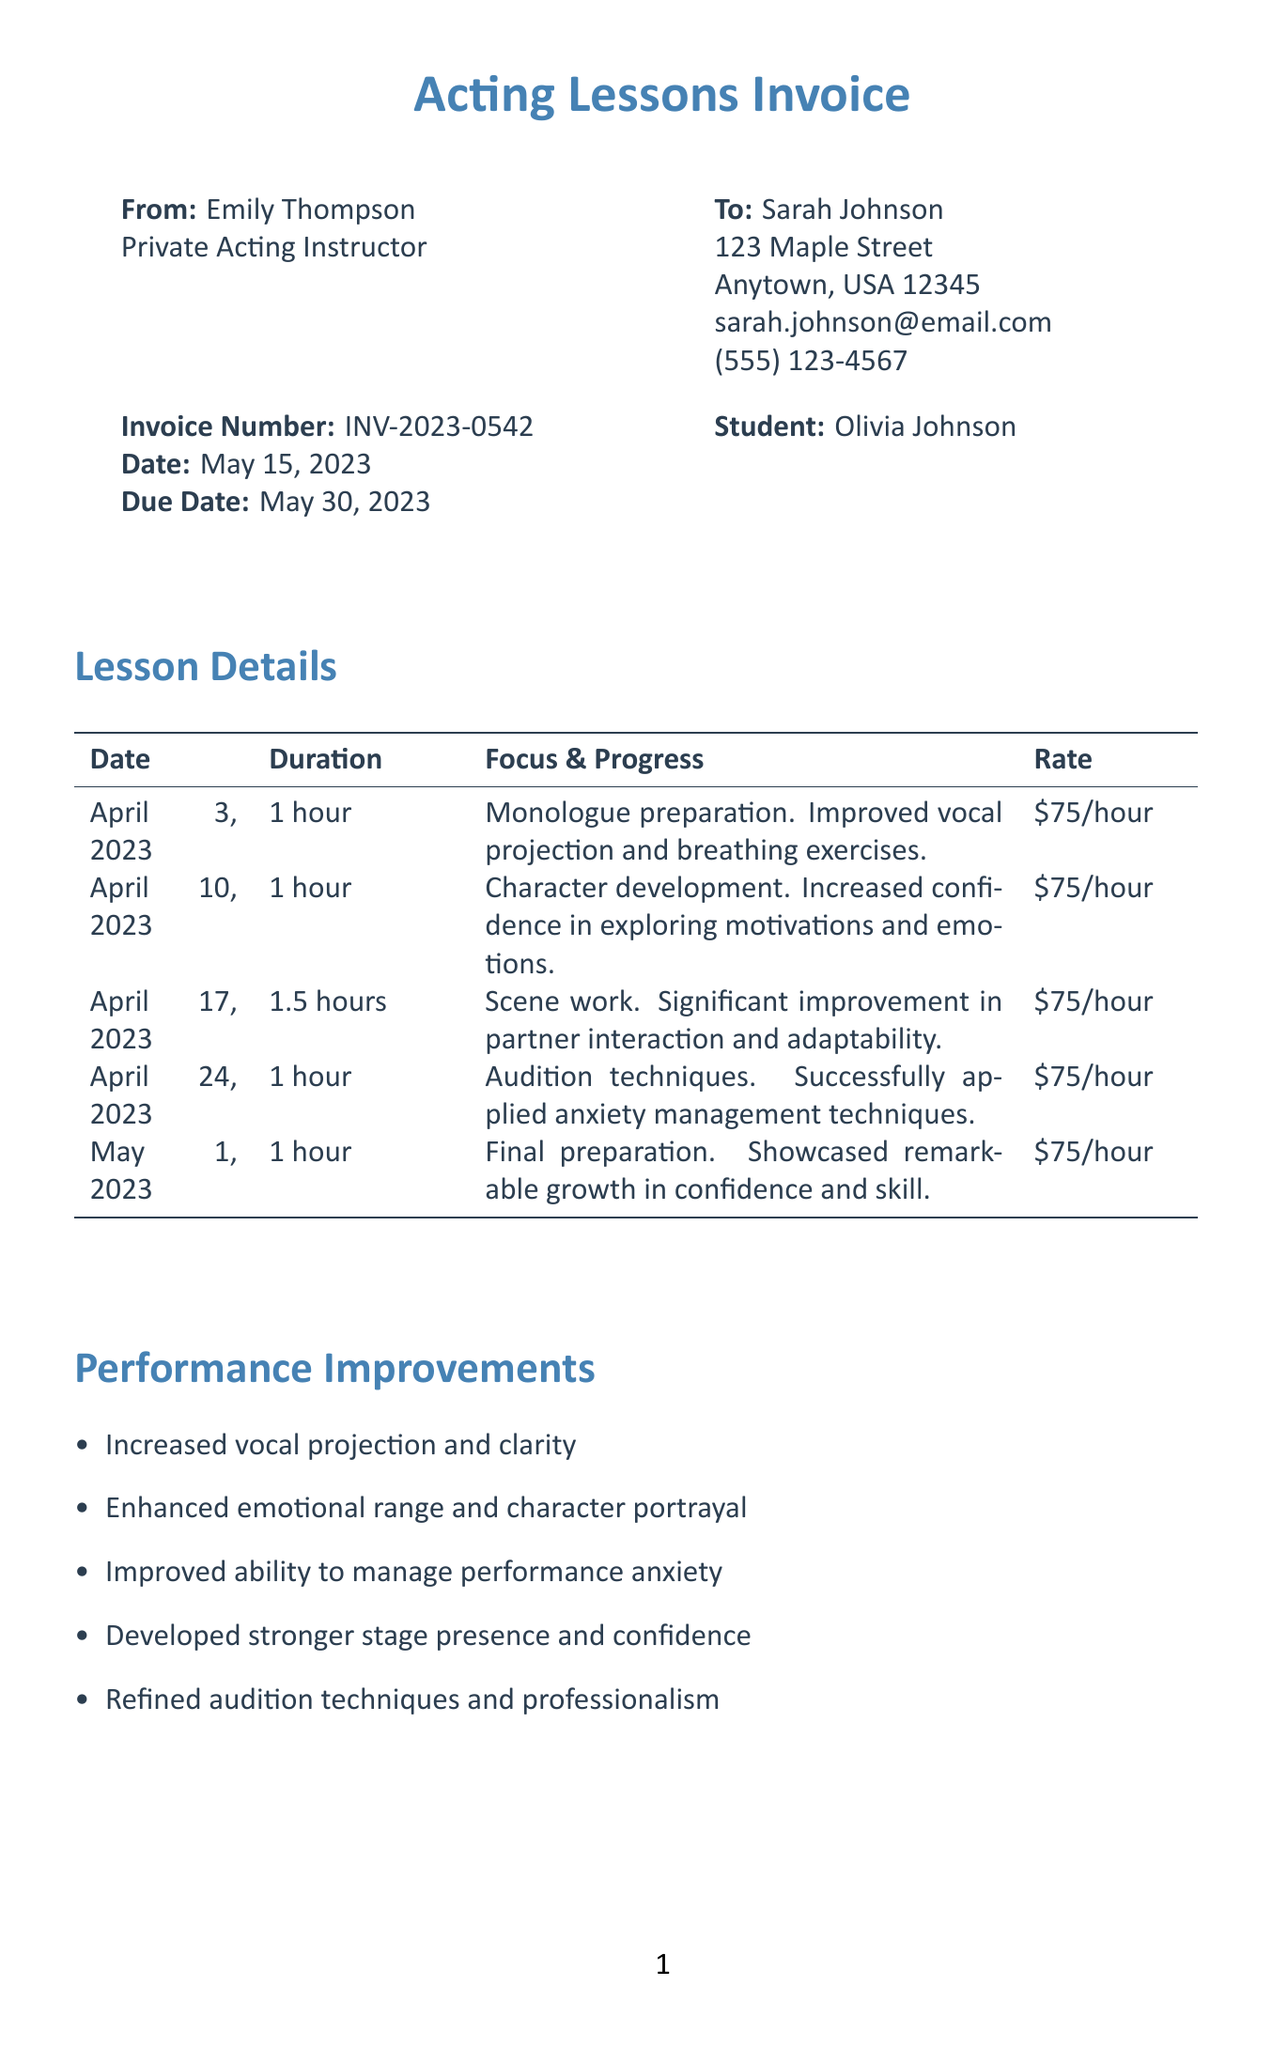What is the invoice number? The invoice number is specified to identify the transaction and is listed as INV-2023-0542.
Answer: INV-2023-0542 Who is the instructor? The instructor's name is provided at the beginning of the document, which is Emily Thompson.
Answer: Emily Thompson What is the total due amount? The total due is calculated after applying the discount to the subtotal and is stated as $375.00.
Answer: $375.00 What was the focus of the lesson on April 10, 2023? The document specifies lesson focuses, and for April 10, it was character development and emotional expression.
Answer: Character development and emotional expression How many hours of lessons did Olivia take? The total hours of all lessons are summarized in the payment section and amount to 5.5 hours.
Answer: 5.5 What discount was applied? The document mentions a discount given for being a new student, which is noted as $37.50.
Answer: $37.50 What type of payment methods are available? The invoice includes payment methods listed at the end, which are Check, Venmo, and PayPal.
Answer: Check, Venmo, PayPal What was noted as a significant improvement for Olivia? Several performance enhancements are listed, with one noted as improved ability to manage performance anxiety.
Answer: Improved ability to manage performance anxiety What is the date of the invoice? The date is crucial for billing cycles and is stated explicitly as May 15, 2023.
Answer: May 15, 2023 